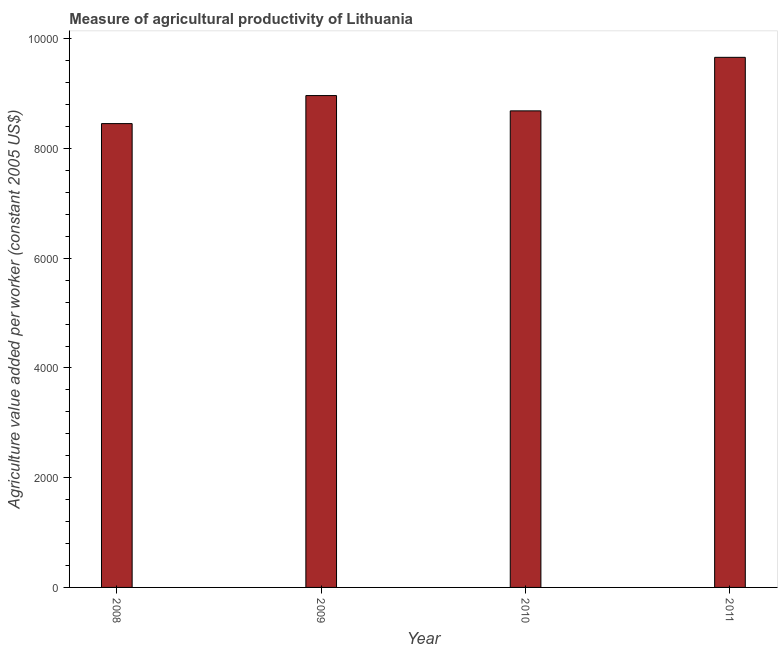Does the graph contain grids?
Your answer should be very brief. No. What is the title of the graph?
Your answer should be compact. Measure of agricultural productivity of Lithuania. What is the label or title of the X-axis?
Your answer should be compact. Year. What is the label or title of the Y-axis?
Offer a terse response. Agriculture value added per worker (constant 2005 US$). What is the agriculture value added per worker in 2009?
Your response must be concise. 8965.99. Across all years, what is the maximum agriculture value added per worker?
Ensure brevity in your answer.  9663.01. Across all years, what is the minimum agriculture value added per worker?
Keep it short and to the point. 8454.91. What is the sum of the agriculture value added per worker?
Make the answer very short. 3.58e+04. What is the difference between the agriculture value added per worker in 2008 and 2009?
Offer a very short reply. -511.08. What is the average agriculture value added per worker per year?
Provide a succinct answer. 8942.78. What is the median agriculture value added per worker?
Your answer should be compact. 8826.6. In how many years, is the agriculture value added per worker greater than 4400 US$?
Your answer should be compact. 4. Do a majority of the years between 2009 and 2011 (inclusive) have agriculture value added per worker greater than 7200 US$?
Your answer should be compact. Yes. What is the ratio of the agriculture value added per worker in 2009 to that in 2010?
Give a very brief answer. 1.03. Is the agriculture value added per worker in 2008 less than that in 2011?
Provide a short and direct response. Yes. Is the difference between the agriculture value added per worker in 2009 and 2010 greater than the difference between any two years?
Offer a terse response. No. What is the difference between the highest and the second highest agriculture value added per worker?
Provide a short and direct response. 697.02. Is the sum of the agriculture value added per worker in 2008 and 2011 greater than the maximum agriculture value added per worker across all years?
Make the answer very short. Yes. What is the difference between the highest and the lowest agriculture value added per worker?
Provide a succinct answer. 1208.1. In how many years, is the agriculture value added per worker greater than the average agriculture value added per worker taken over all years?
Your answer should be very brief. 2. How many bars are there?
Provide a succinct answer. 4. Are all the bars in the graph horizontal?
Make the answer very short. No. What is the difference between two consecutive major ticks on the Y-axis?
Keep it short and to the point. 2000. Are the values on the major ticks of Y-axis written in scientific E-notation?
Give a very brief answer. No. What is the Agriculture value added per worker (constant 2005 US$) of 2008?
Your answer should be compact. 8454.91. What is the Agriculture value added per worker (constant 2005 US$) of 2009?
Keep it short and to the point. 8965.99. What is the Agriculture value added per worker (constant 2005 US$) in 2010?
Keep it short and to the point. 8687.21. What is the Agriculture value added per worker (constant 2005 US$) of 2011?
Keep it short and to the point. 9663.01. What is the difference between the Agriculture value added per worker (constant 2005 US$) in 2008 and 2009?
Your answer should be very brief. -511.08. What is the difference between the Agriculture value added per worker (constant 2005 US$) in 2008 and 2010?
Ensure brevity in your answer.  -232.3. What is the difference between the Agriculture value added per worker (constant 2005 US$) in 2008 and 2011?
Keep it short and to the point. -1208.1. What is the difference between the Agriculture value added per worker (constant 2005 US$) in 2009 and 2010?
Ensure brevity in your answer.  278.78. What is the difference between the Agriculture value added per worker (constant 2005 US$) in 2009 and 2011?
Make the answer very short. -697.02. What is the difference between the Agriculture value added per worker (constant 2005 US$) in 2010 and 2011?
Offer a very short reply. -975.8. What is the ratio of the Agriculture value added per worker (constant 2005 US$) in 2008 to that in 2009?
Offer a terse response. 0.94. What is the ratio of the Agriculture value added per worker (constant 2005 US$) in 2009 to that in 2010?
Provide a succinct answer. 1.03. What is the ratio of the Agriculture value added per worker (constant 2005 US$) in 2009 to that in 2011?
Ensure brevity in your answer.  0.93. What is the ratio of the Agriculture value added per worker (constant 2005 US$) in 2010 to that in 2011?
Your answer should be compact. 0.9. 